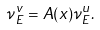Convert formula to latex. <formula><loc_0><loc_0><loc_500><loc_500>\nu _ { E } ^ { v } = A ( x ) \nu _ { E } ^ { u } .</formula> 